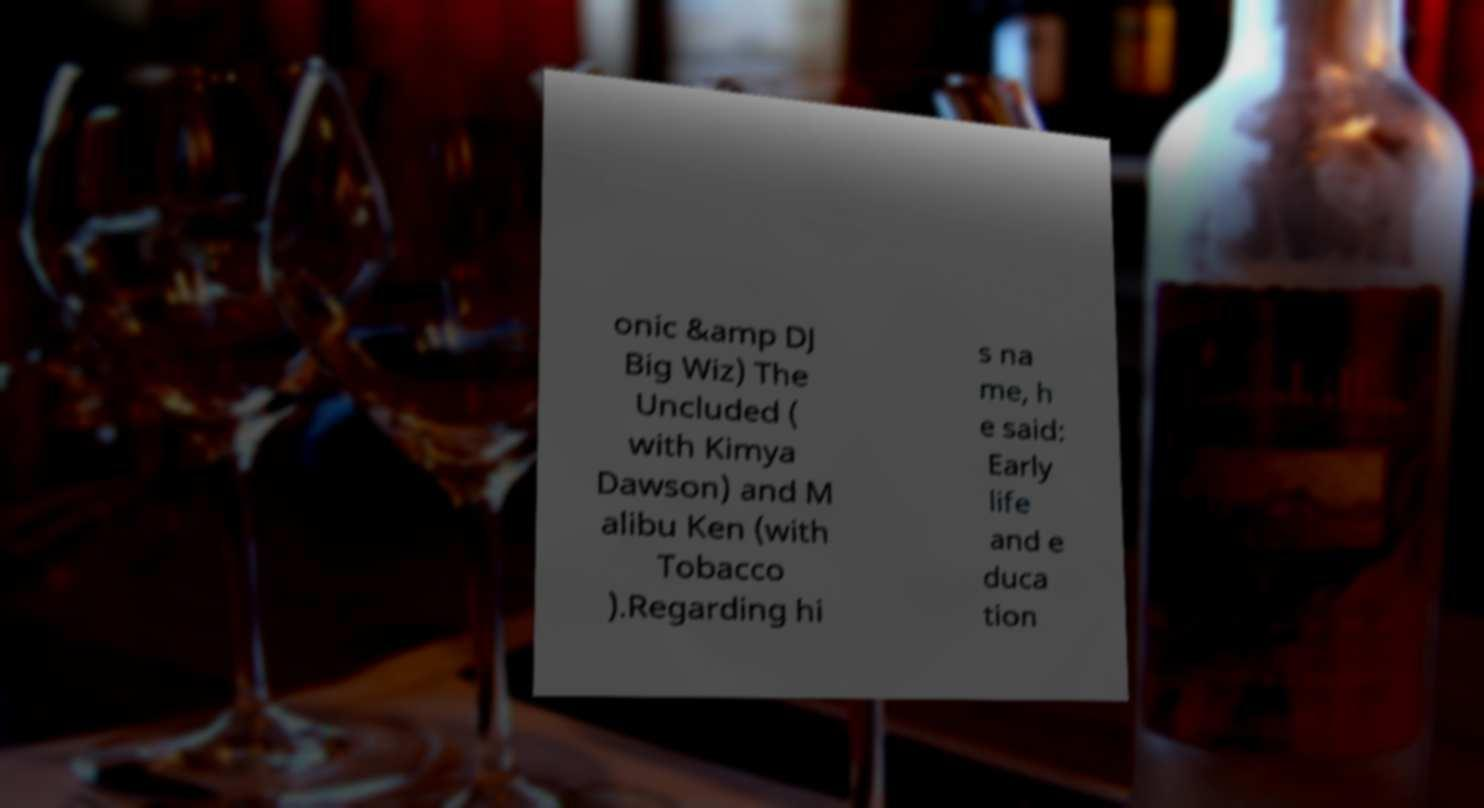Please identify and transcribe the text found in this image. onic &amp DJ Big Wiz) The Uncluded ( with Kimya Dawson) and M alibu Ken (with Tobacco ).Regarding hi s na me, h e said: Early life and e duca tion 